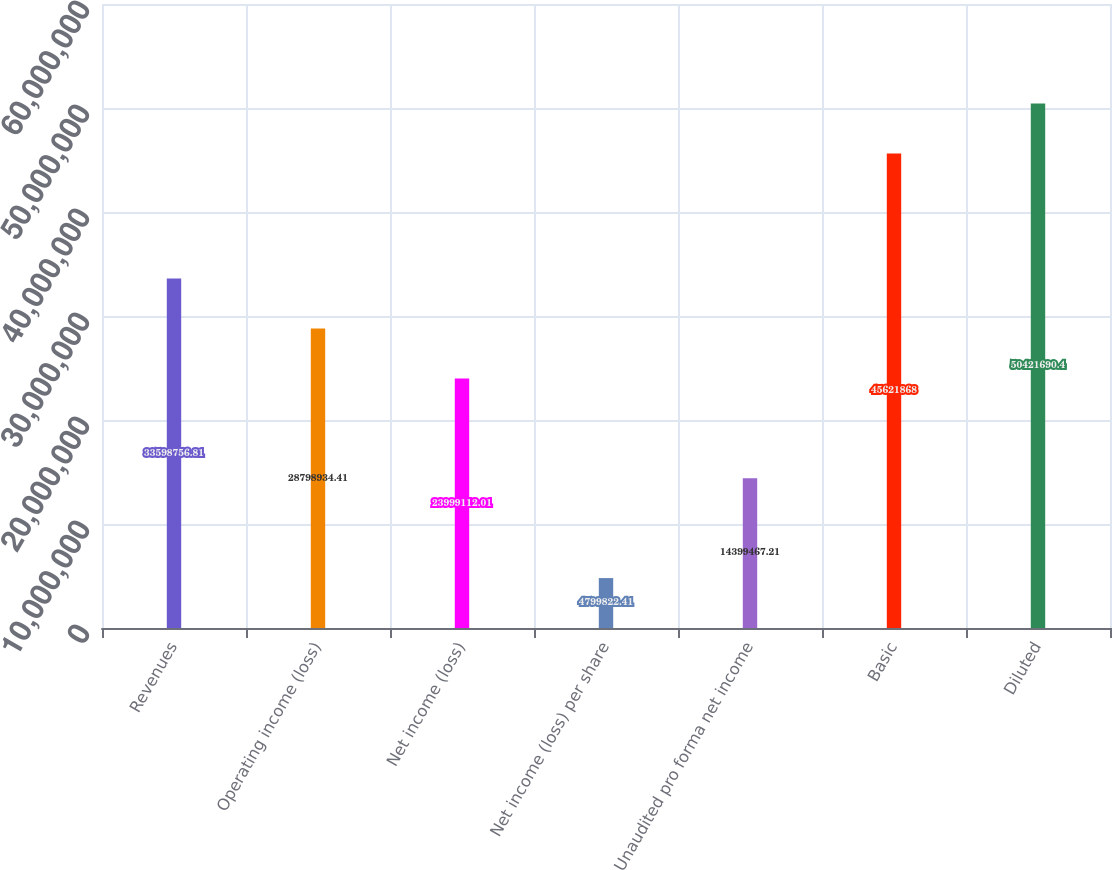Convert chart to OTSL. <chart><loc_0><loc_0><loc_500><loc_500><bar_chart><fcel>Revenues<fcel>Operating income (loss)<fcel>Net income (loss)<fcel>Net income (loss) per share<fcel>Unaudited pro forma net income<fcel>Basic<fcel>Diluted<nl><fcel>3.35988e+07<fcel>2.87989e+07<fcel>2.39991e+07<fcel>4.79982e+06<fcel>1.43995e+07<fcel>4.56219e+07<fcel>5.04217e+07<nl></chart> 